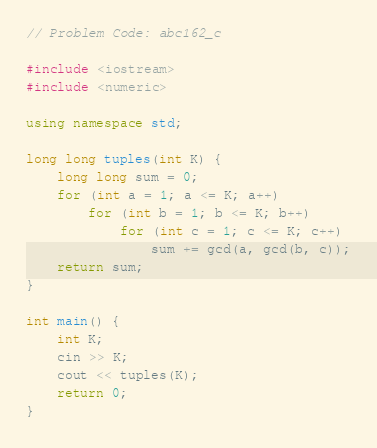Convert code to text. <code><loc_0><loc_0><loc_500><loc_500><_C++_>// Problem Code: abc162_c

#include <iostream>
#include <numeric>

using namespace std;

long long tuples(int K) {
	long long sum = 0;
	for (int a = 1; a <= K; a++)
		for (int b = 1; b <= K; b++)
			for (int c = 1; c <= K; c++)
				sum += gcd(a, gcd(b, c));
	return sum;
}

int main() {
	int K;
	cin >> K;
	cout << tuples(K);
	return 0;
}</code> 